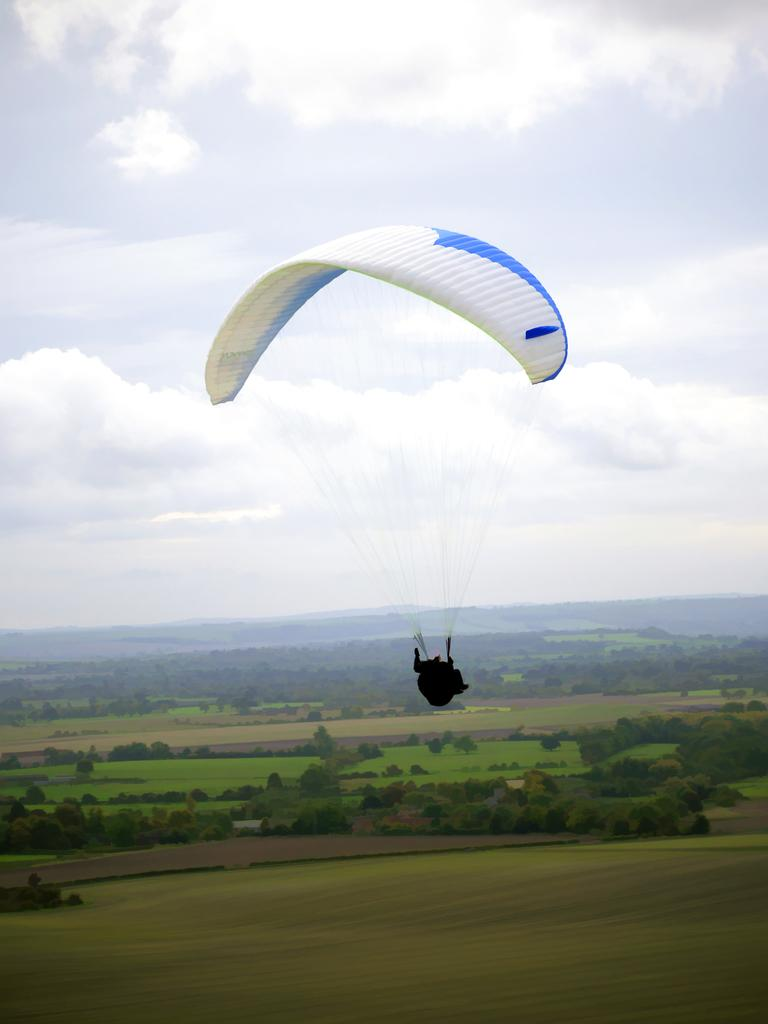What is the main subject of the image? There is a person in the image. What is the person doing in the image? The person is parachuting in the air. What can be seen in the background of the image? There are trees, hills, and the sky visible in the background of the image. What type of advice can be heard being given to the person in the image? There is no dialogue or audio present in the image, so it is not possible to determine what advice might be given. 